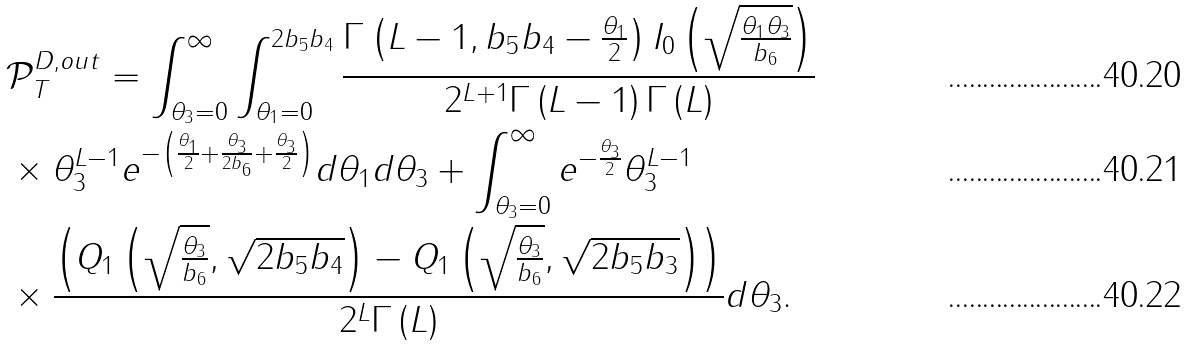Convert formula to latex. <formula><loc_0><loc_0><loc_500><loc_500>& \mathcal { P } _ { T } ^ { D , o u t } = \int _ { \theta _ { 3 } = 0 } ^ { \infty } \int _ { \theta _ { 1 } = 0 } ^ { 2 b _ { 5 } b _ { 4 } } \frac { \Gamma \left ( L - 1 , b _ { 5 } b _ { 4 } - \frac { \theta _ { 1 } } { 2 } \right ) I _ { 0 } \left ( \sqrt { \frac { \theta _ { 1 } \theta _ { 3 } } { b _ { 6 } } } \right ) } { 2 ^ { L + 1 } \Gamma \left ( L - 1 \right ) \Gamma \left ( L \right ) } \\ & \times \theta _ { 3 } ^ { L - 1 } e ^ { - \left ( \frac { \theta _ { 1 } } { 2 } + \frac { \theta _ { 3 } } { 2 b _ { 6 } } + \frac { \theta _ { 3 } } { 2 } \right ) } d \theta _ { 1 } d \theta _ { 3 } + \int _ { \theta _ { 3 } = 0 } ^ { \infty } e ^ { - \frac { \theta _ { 3 } } { 2 } } \theta _ { 3 } ^ { L - 1 } \\ & \times \frac { \left ( Q _ { 1 } \left ( \sqrt { \frac { \theta _ { 3 } } { b _ { 6 } } } , \sqrt { 2 b _ { 5 } b _ { 4 } } \right ) - Q _ { 1 } \left ( \sqrt { \frac { \theta _ { 3 } } { b _ { 6 } } } , \sqrt { 2 b _ { 5 } b _ { 3 } } \right ) \right ) } { 2 ^ { L } \Gamma \left ( L \right ) } d \theta _ { 3 } .</formula> 